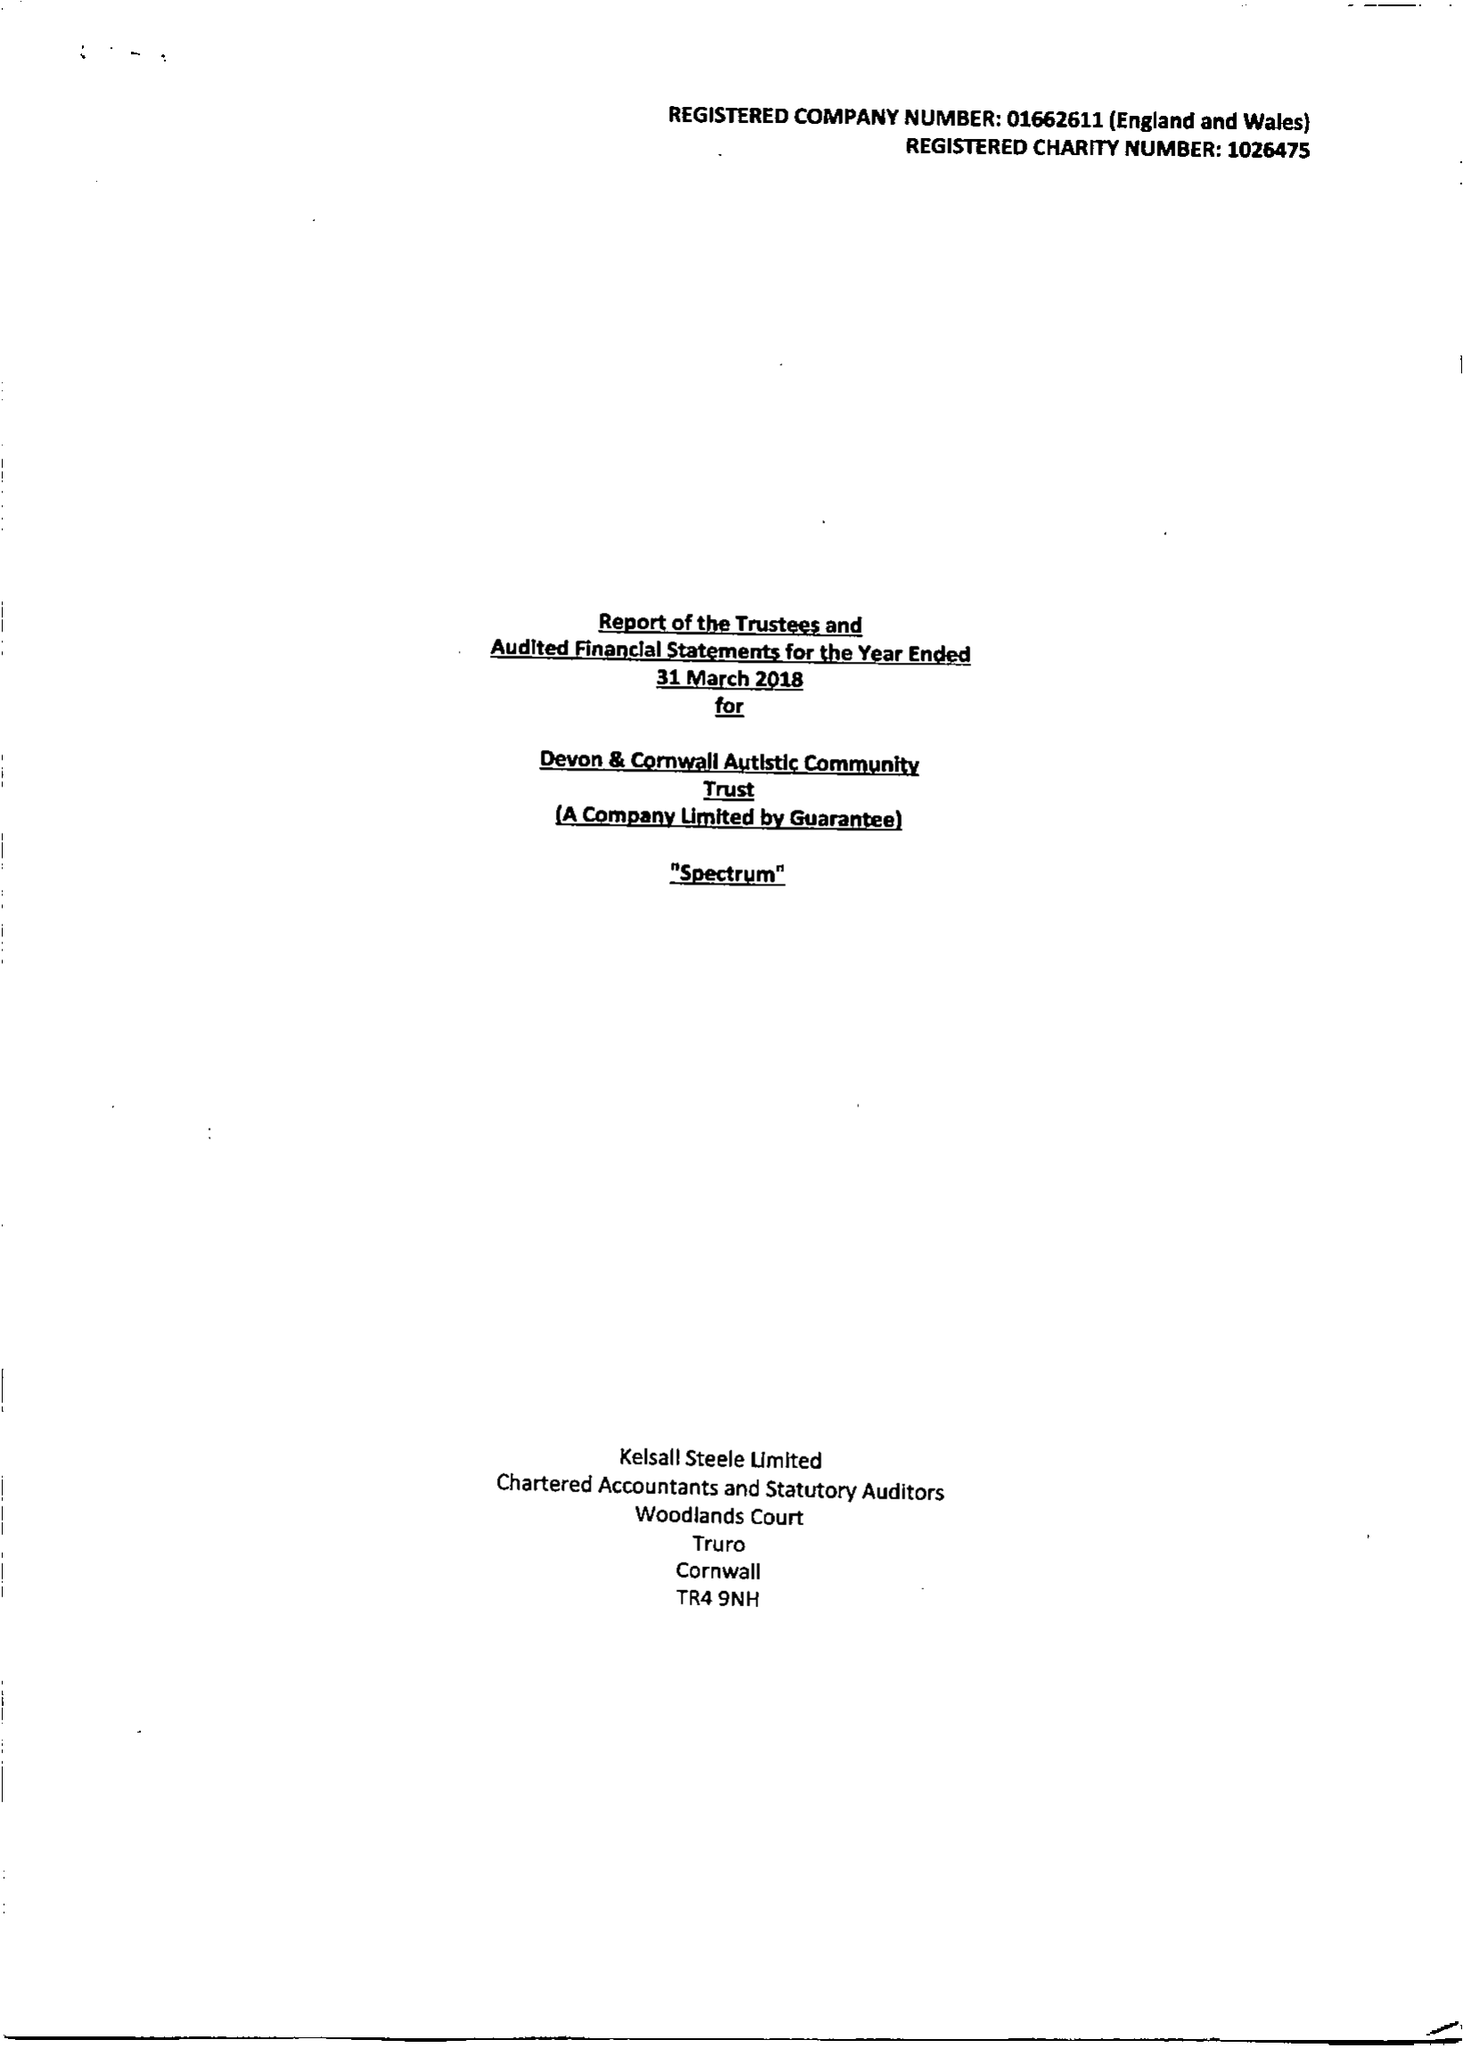What is the value for the report_date?
Answer the question using a single word or phrase. 2018-03-31 